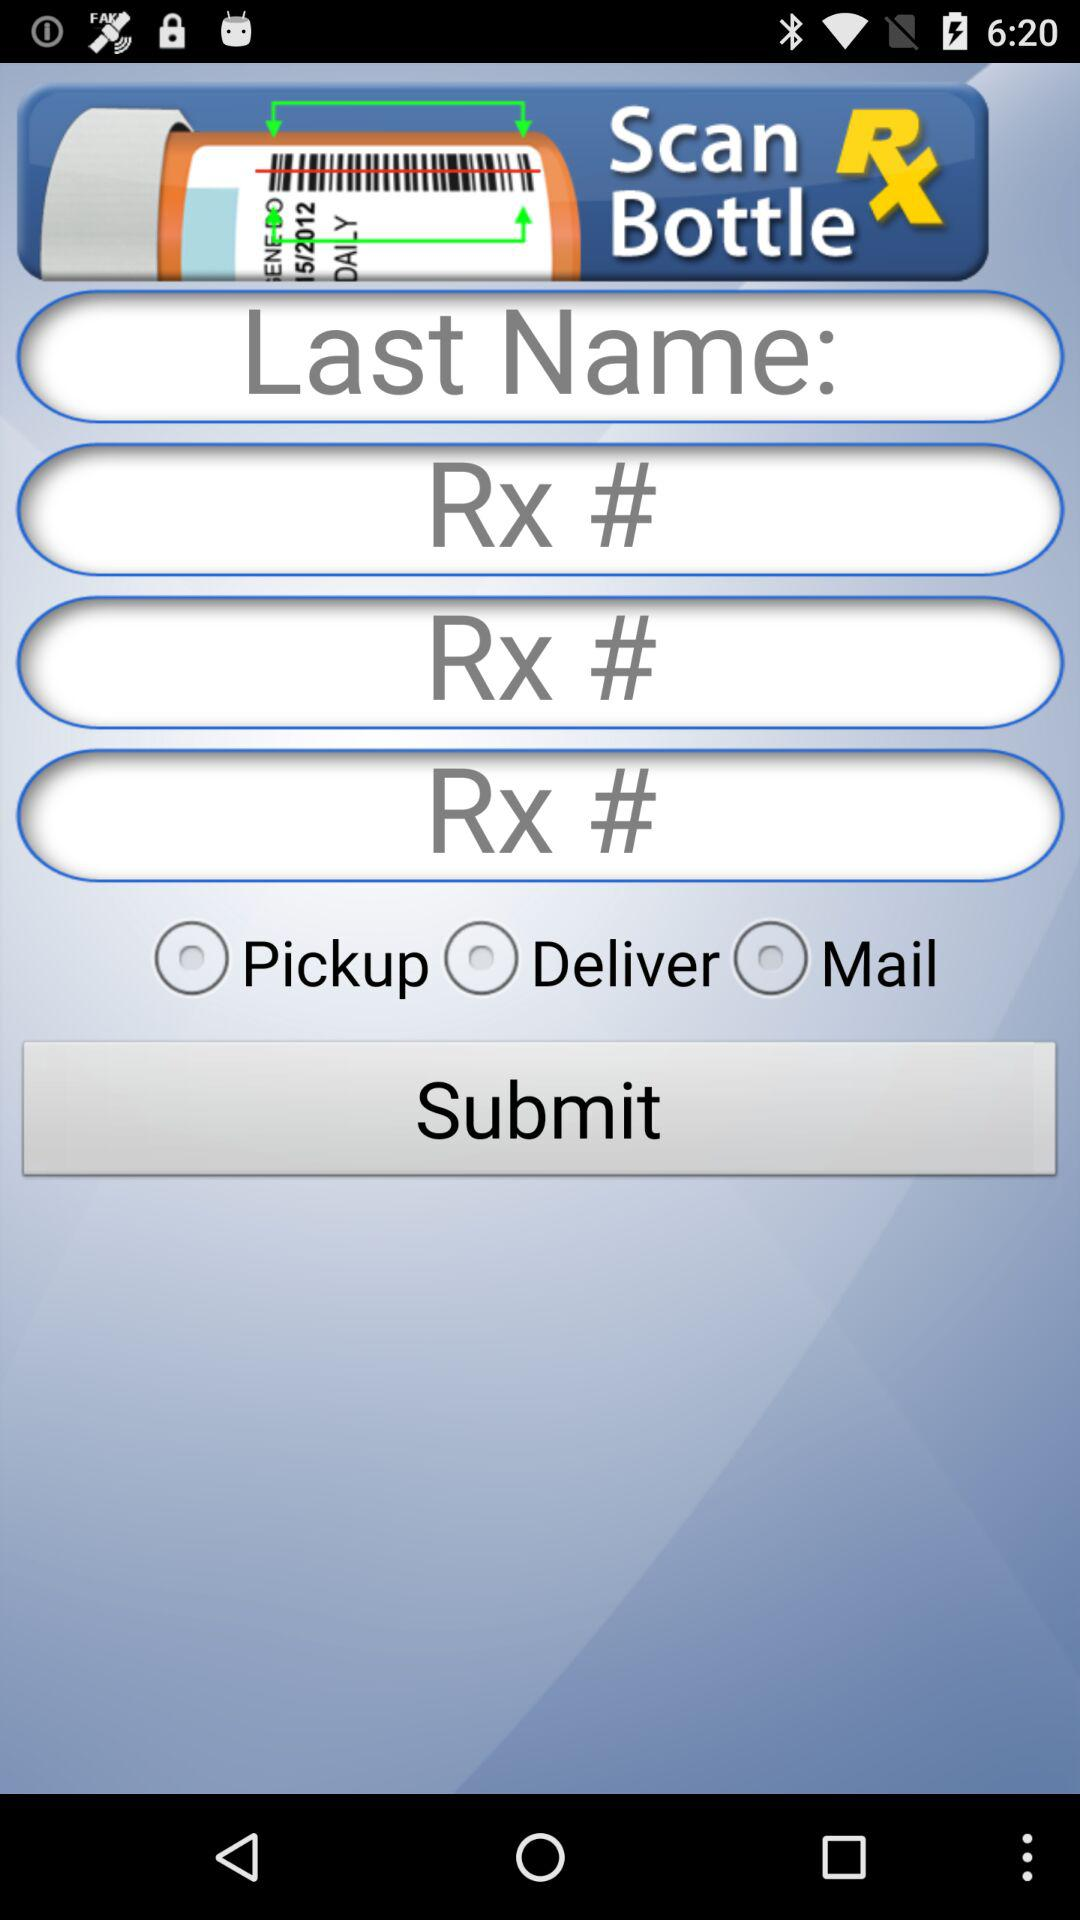How many RADIO_BUTTONS are there on the screen?
Answer the question using a single word or phrase. 3 